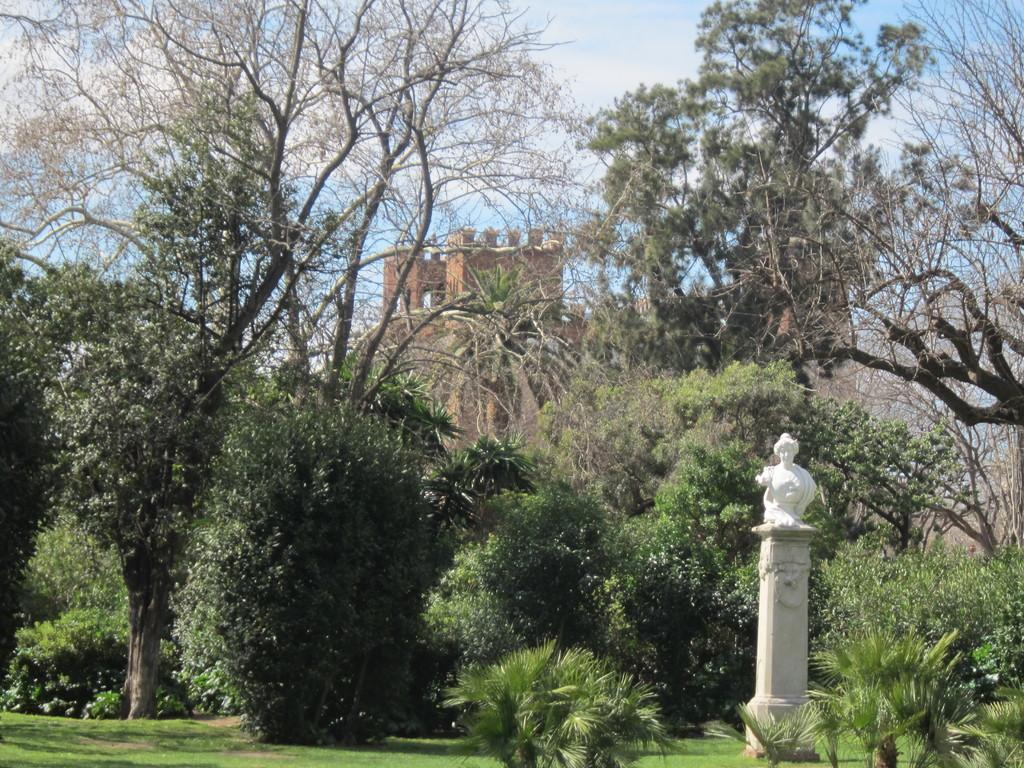What type of living organisms can be seen in the image? Plants and trees are visible in the image. What is located on the right side of the image? There is a statue on the right side of the image. What type of structure can be seen in the background of the image? There is a fort in the background of the image. Can you hear the rhythm of the cat purring in the image? There is no cat present in the image, so it is not possible to hear any purring or rhythm. 